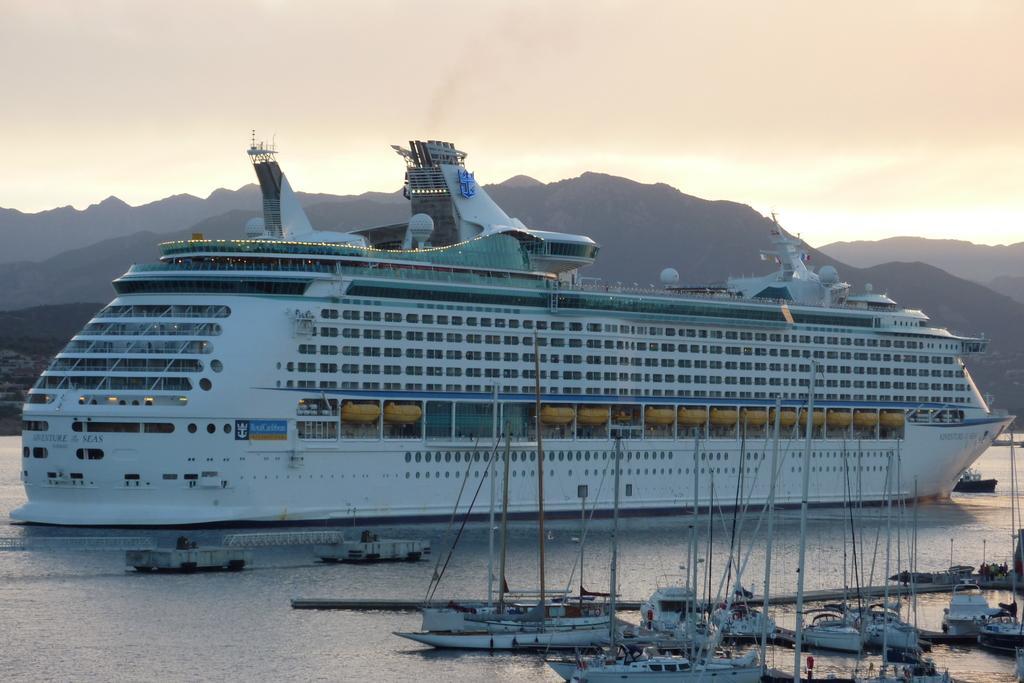Describe this image in one or two sentences. In the foreground of the picture there are boats. In the center of the picture there is a ship. In this picture there is a water body. In the background there are hills. 